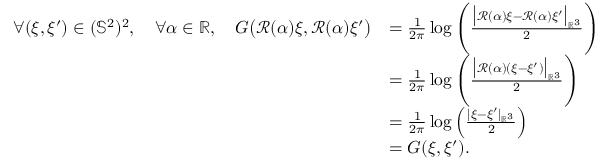<formula> <loc_0><loc_0><loc_500><loc_500>\begin{array} { r l } { \forall ( \xi , \xi ^ { \prime } ) \in ( \mathbb { S } ^ { 2 } ) ^ { 2 } , \quad \forall \alpha \in \mathbb { R } , \quad G \left ( \mathcal { R } ( \alpha ) \xi , \mathcal { R } ( \alpha ) \xi ^ { \prime } \right ) } & { = \frac { 1 } { 2 \pi } \log \left ( \frac { \left | \mathcal { R } ( \alpha ) \xi - \mathcal { R } ( \alpha ) \xi ^ { \prime } \right | _ { \mathbb { R } ^ { 3 } } } { 2 } \right ) } \\ & { = \frac { 1 } { 2 \pi } \log \left ( \frac { \left | \mathcal { R } ( \alpha ) ( \xi - \xi ^ { \prime } ) \right | _ { \mathbb { R } ^ { 3 } } } { 2 } \right ) } \\ & { = \frac { 1 } { 2 \pi } \log \left ( \frac { | \xi - \xi ^ { \prime } | _ { \mathbb { R } ^ { 3 } } } { 2 } \right ) } \\ & { = G ( \xi , \xi ^ { \prime } ) . } \end{array}</formula> 